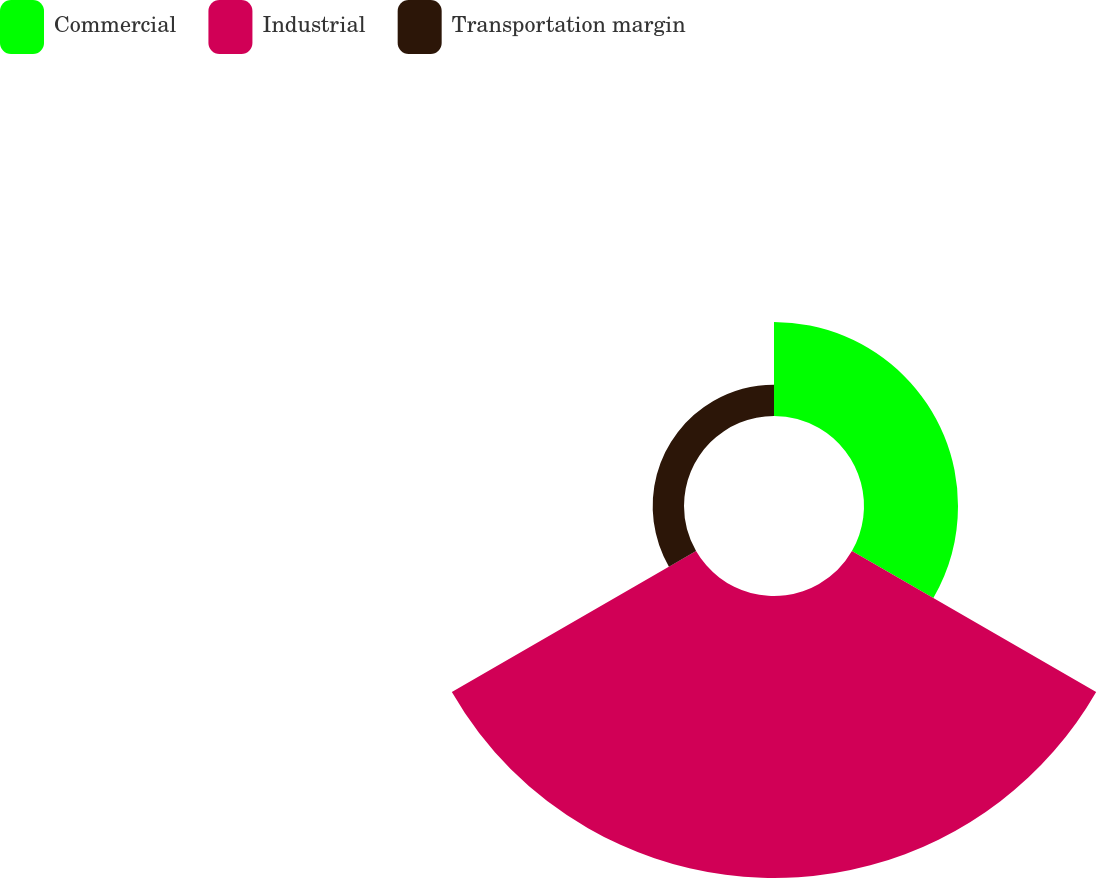<chart> <loc_0><loc_0><loc_500><loc_500><pie_chart><fcel>Commercial<fcel>Industrial<fcel>Transportation margin<nl><fcel>23.08%<fcel>69.23%<fcel>7.69%<nl></chart> 